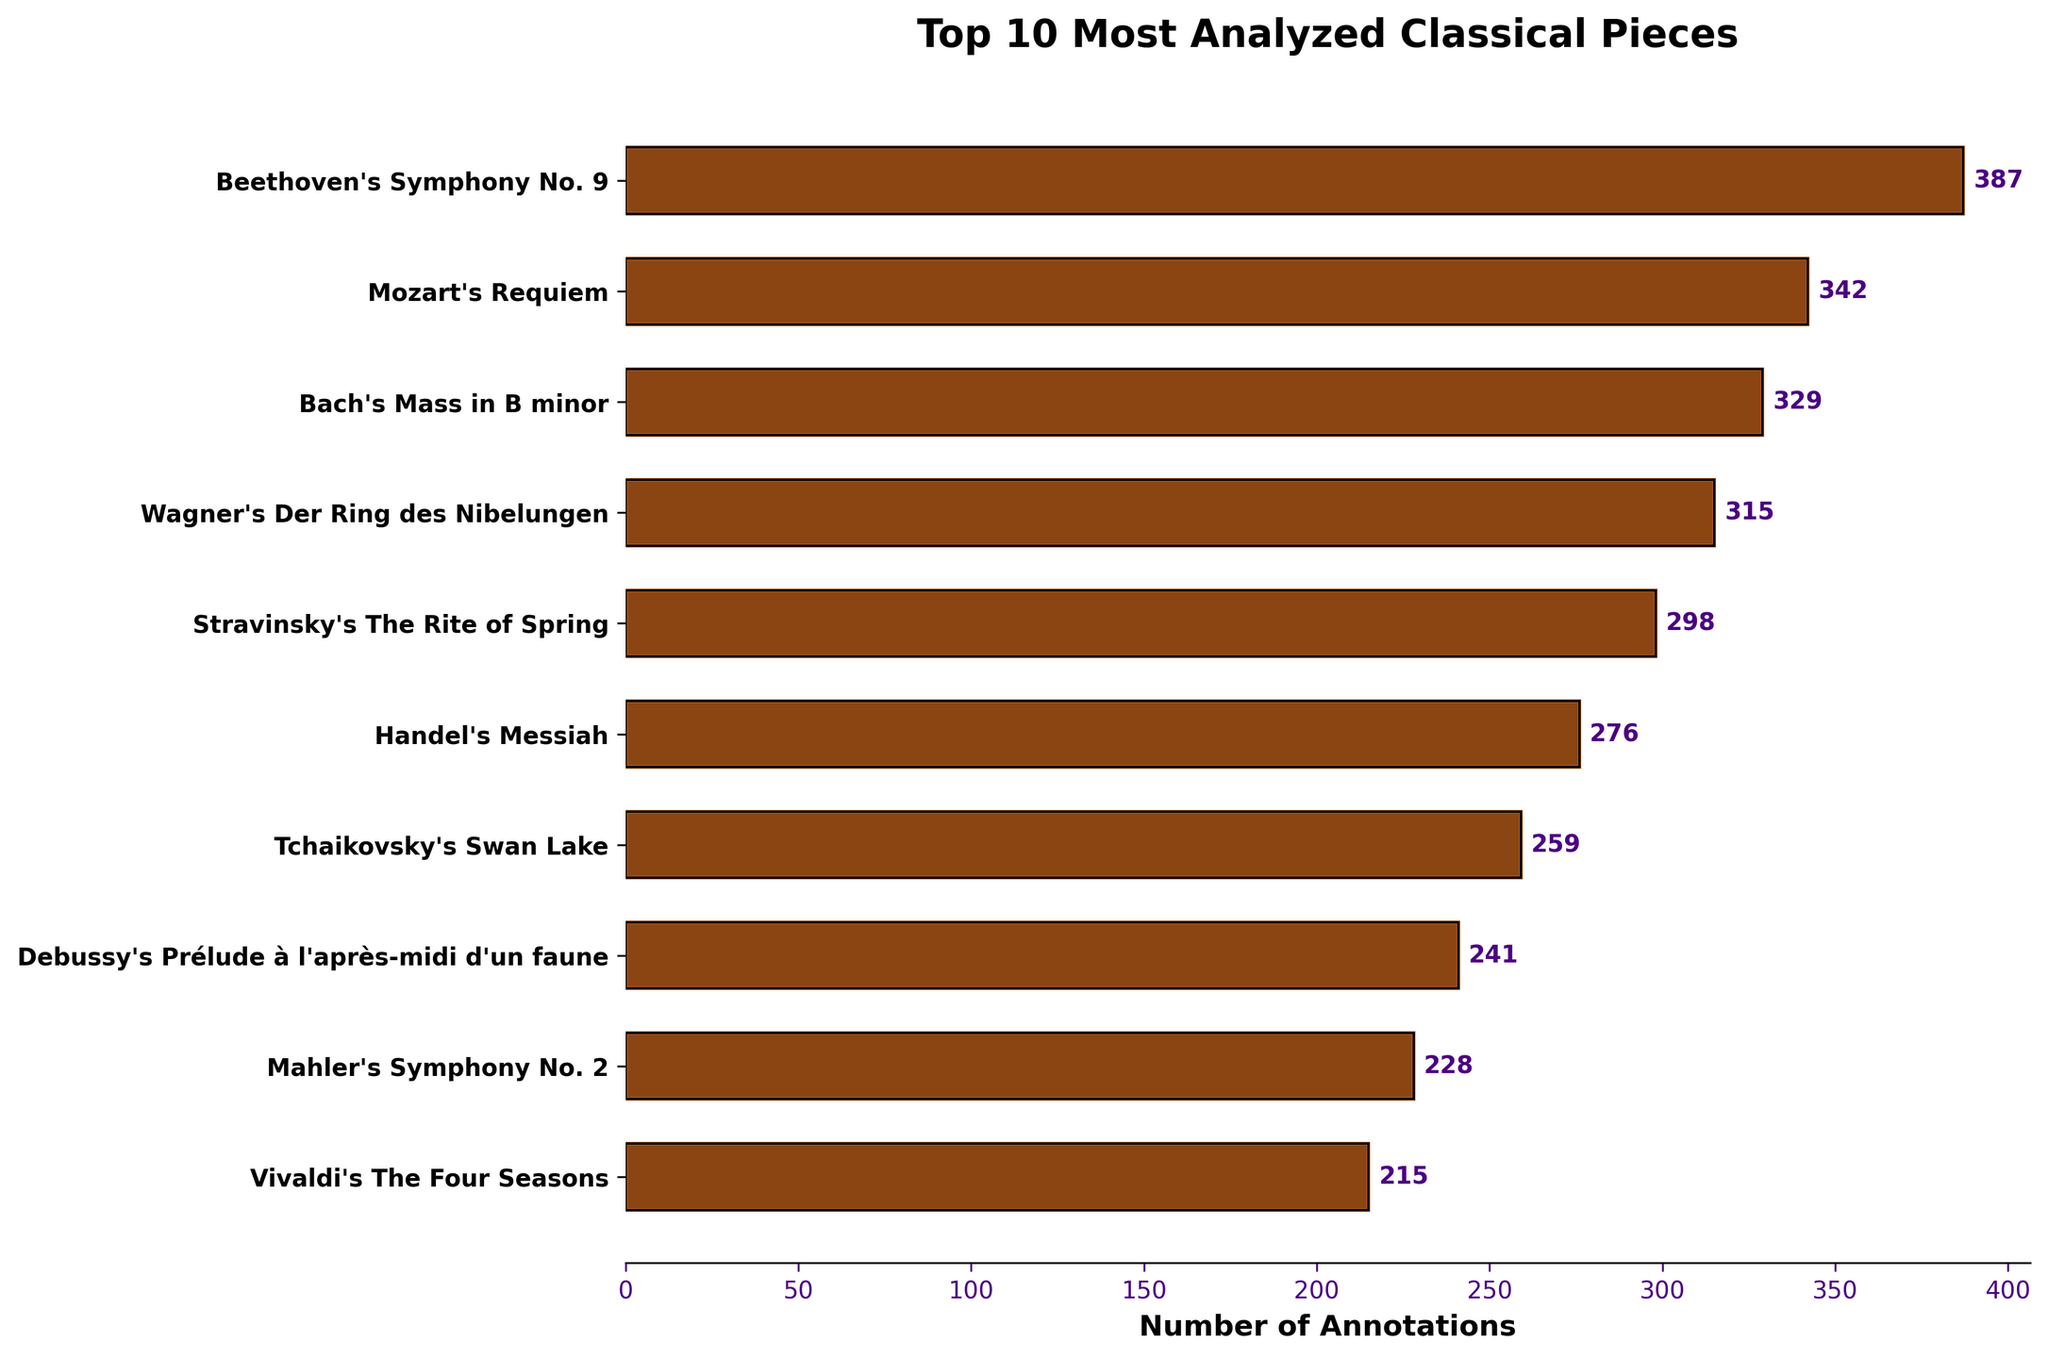Which piece has the highest number of annotations? The bar representing Beethoven's Symphony No. 9 extends the farthest to the right, indicating it has the highest number of annotations.
Answer: Beethoven's Symphony No. 9 Which two pieces have the closest number of annotations? By observing the lengths of the bars, the bars for Wagner's Der Ring des Nibelungen and Stravinsky's The Rite of Spring are closest in length, indicating their annotation numbers are close.
Answer: Wagner's Der Ring des Nibelungen and Stravinsky's The Rite of Spring What is the total number of annotations for the top 3 most analyzed pieces? Summing the annotations for Beethoven's Symphony No. 9, Mozart's Requiem, and Bach's Mass in B minor: 387 + 342 + 329 = 1058.
Answer: 1058 Is the number of annotations for Tchaikovsky's Swan Lake greater than that for Debussy's Prélude à l'après-midi d'un faune? Comparing the lengths of the corresponding bars, Tchaikovsky's Swan Lake has a slightly longer bar, indicating it has more annotations.
Answer: Yes How much greater is the number of annotations for Handel's Messiah compared to Vivaldi's The Four Seasons? Subtracting the number of annotations for Vivaldi's The Four Seasons from Handel's Messiah: 276 - 215 = 61.
Answer: 61 What is the average number of annotations for all 10 pieces? Summing the annotations: 387 + 342 + 329 + 315 + 298 + 276 + 259 + 241 + 228 + 215 = 2890. Dividing by 10 gives: 2890 / 10 = 289.
Answer: 289 Which piece has the shortest bar in the chart? The bar representing Vivaldi's The Four Seasons extends the least, indicating it has the fewest annotations among the pieces listed.
Answer: Vivaldi's The Four Seasons Are there more annotations on average for pieces by German composers (Beethoven, Bach, Wagner) or by Russian composers (Stravinsky, Tchaikovsky)? Summing annotations for German composers: 387 (Beethoven) + 329 (Bach) + 315 (Wagner) = 1031. Dividing by 3: 1031 / 3 = 343.67. Summing annotations for Russian composers: 298 (Stravinsky) + 259 (Tchaikovsky) = 557. Dividing by 2: 557 / 2 = 278.5. The average for German composers is higher.
Answer: German composers Between Bach's Mass in B minor and Mahler's Symphony No. 2, which has fewer annotations and by how much? Bach's Mass in B minor has 329 annotations, and Mahler's Symphony No. 2 has 228 annotations. Subtracting: 329 - 228 = 101.
Answer: Mahler's Symphony No. 2 by 101 How many pieces have more than 300 annotations? Counting bars with lengths corresponding to more than 300 annotations: Beethoven's Symphony No. 9, Mozart's Requiem, Bach's Mass in B minor, and Wagner's Der Ring des Nibelungen. Total = 4.
Answer: 4 